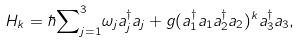Convert formula to latex. <formula><loc_0><loc_0><loc_500><loc_500>H _ { k } = \hbar { \sum } ^ { 3 } _ { j = 1 } { \omega _ { j } } a ^ { \dag } _ { j } a _ { j } + { } g ( a ^ { \dag } _ { 1 } a _ { 1 } a ^ { \dag } _ { 2 } a _ { 2 } ) ^ { k } a ^ { \dag } _ { 3 } a _ { 3 } ,</formula> 